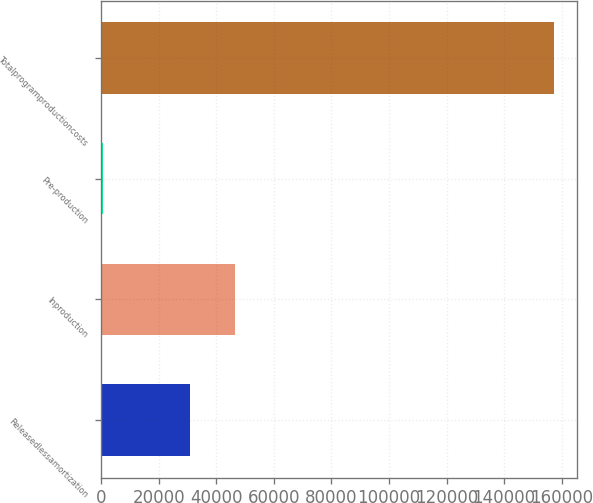Convert chart. <chart><loc_0><loc_0><loc_500><loc_500><bar_chart><fcel>Releasedlessamortization<fcel>Inproduction<fcel>Pre-production<fcel>Totalprogramproductioncosts<nl><fcel>30800<fcel>46486.2<fcel>489<fcel>157351<nl></chart> 